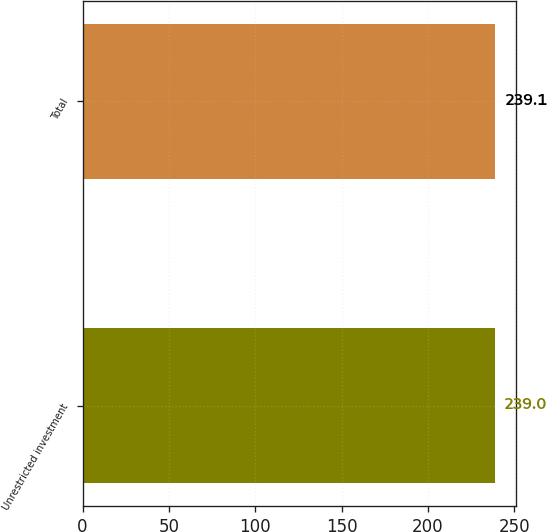Convert chart to OTSL. <chart><loc_0><loc_0><loc_500><loc_500><bar_chart><fcel>Unrestricted investment<fcel>Total<nl><fcel>239<fcel>239.1<nl></chart> 